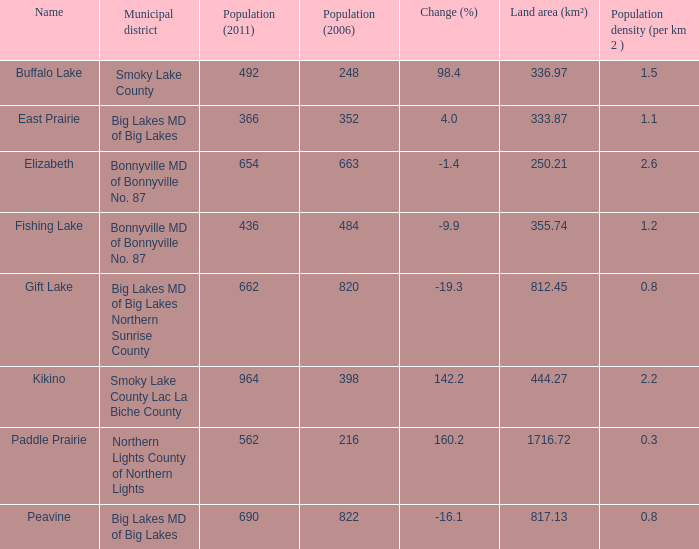What place is there a change of -19.3? 1.0. 